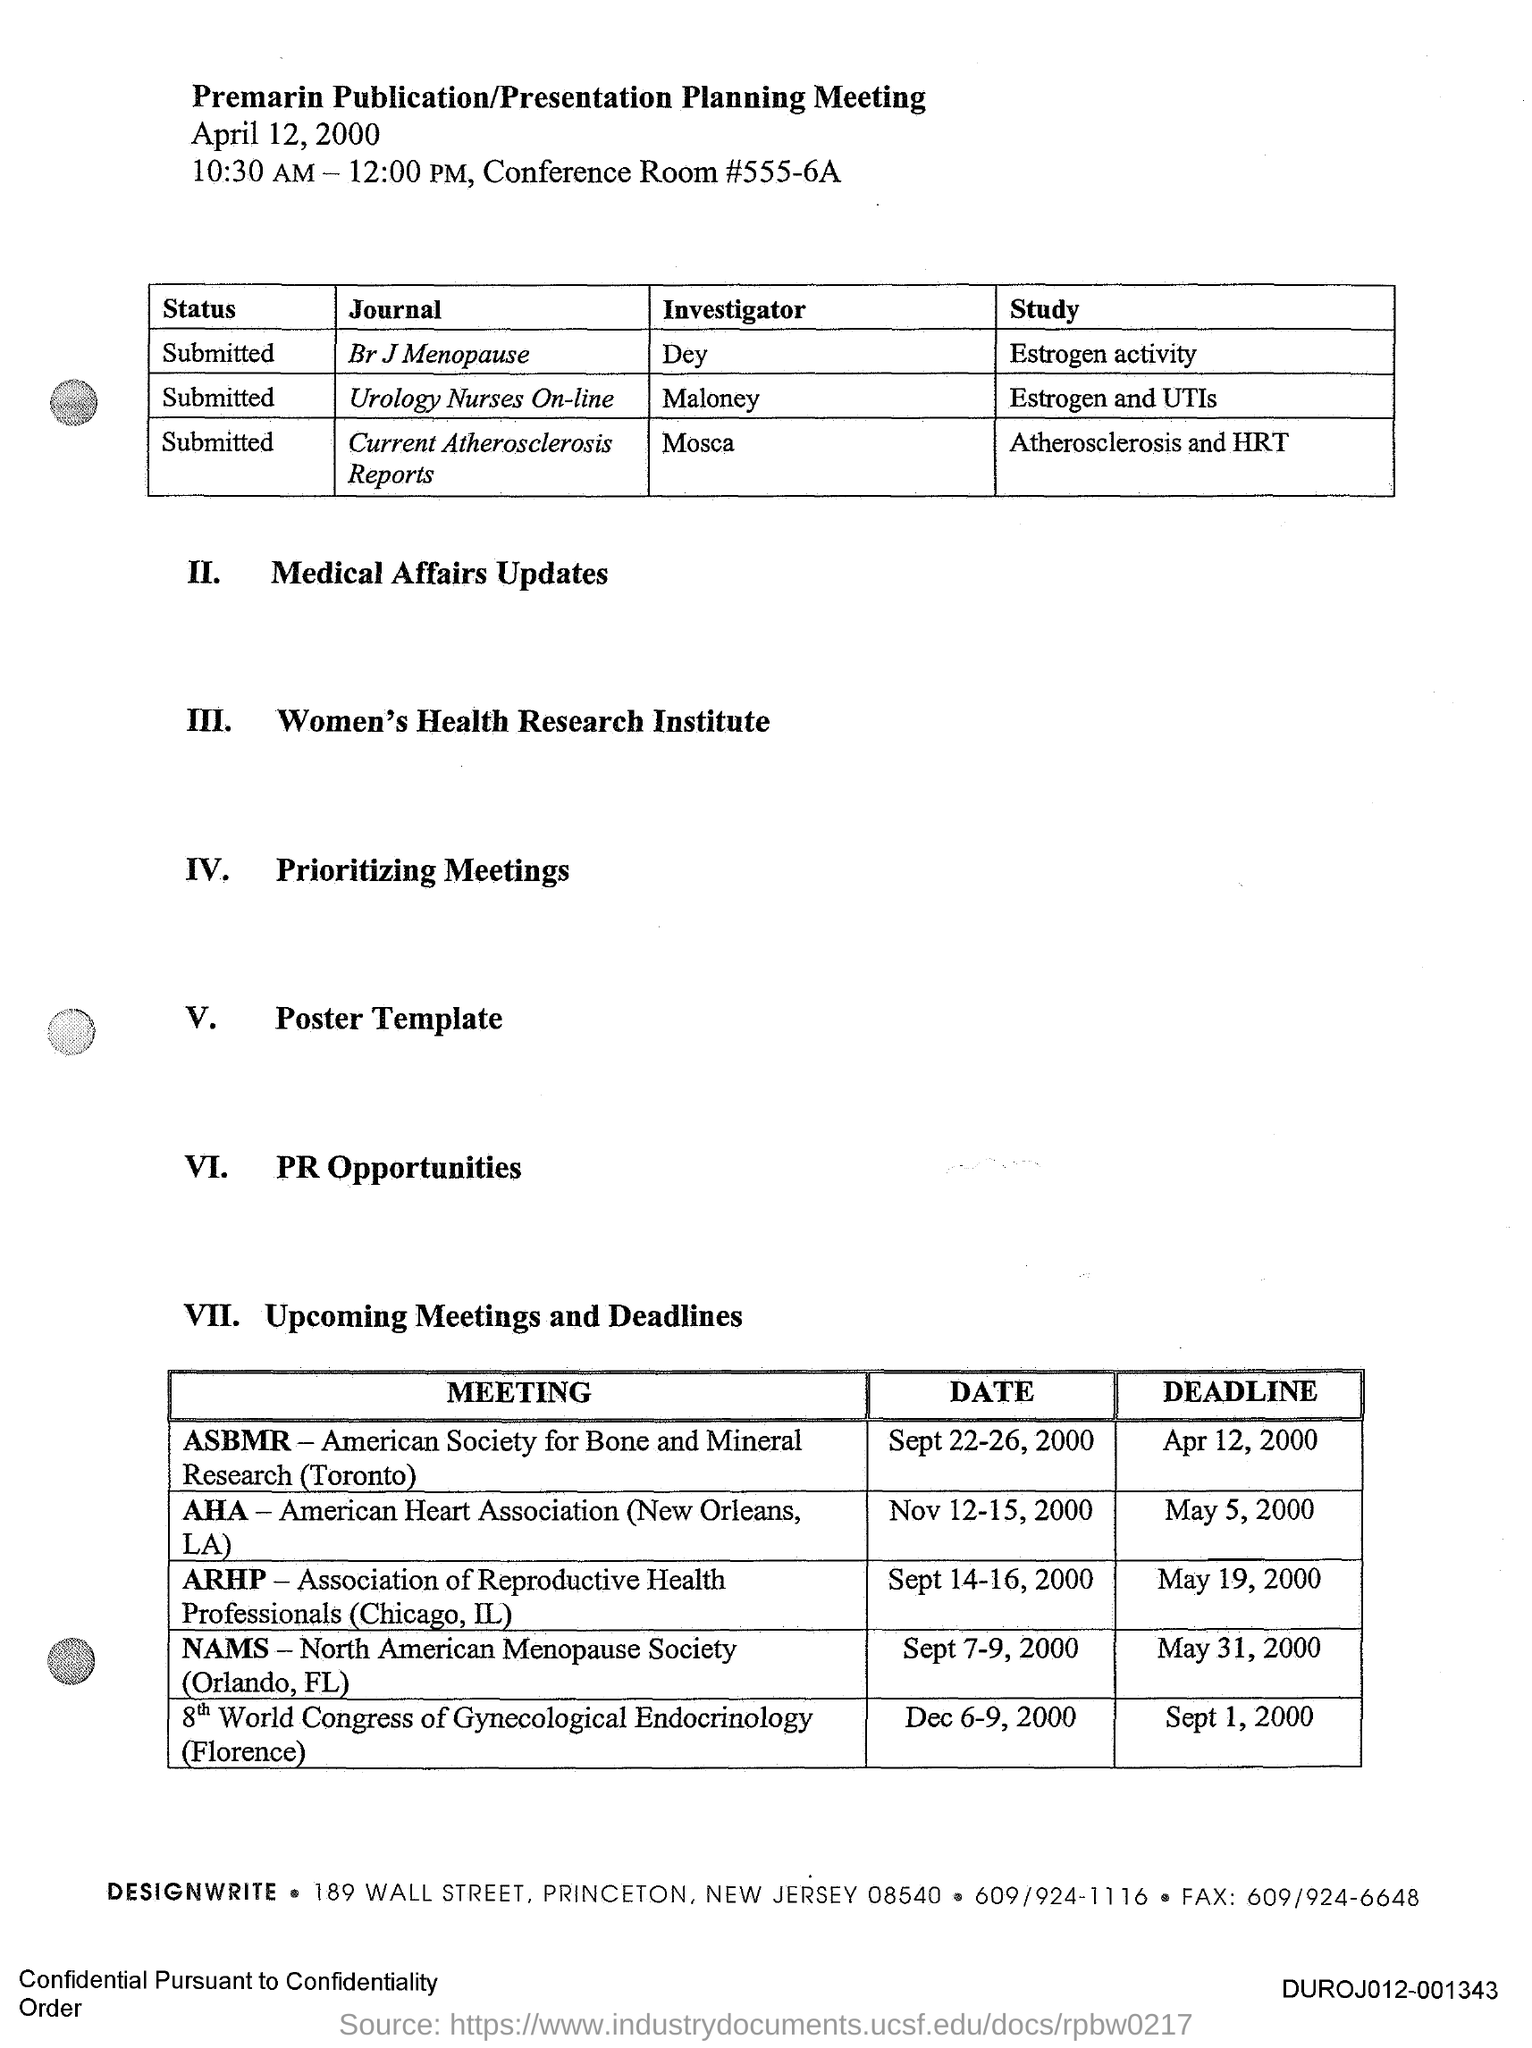Specify some key components in this picture. The document is titled "Premarin Publication/Presentation Planning Meeting. The investigator for the journal Br J Menopause is Dey. The investigator for the journal Urology Nurses On-line is Maloney. 